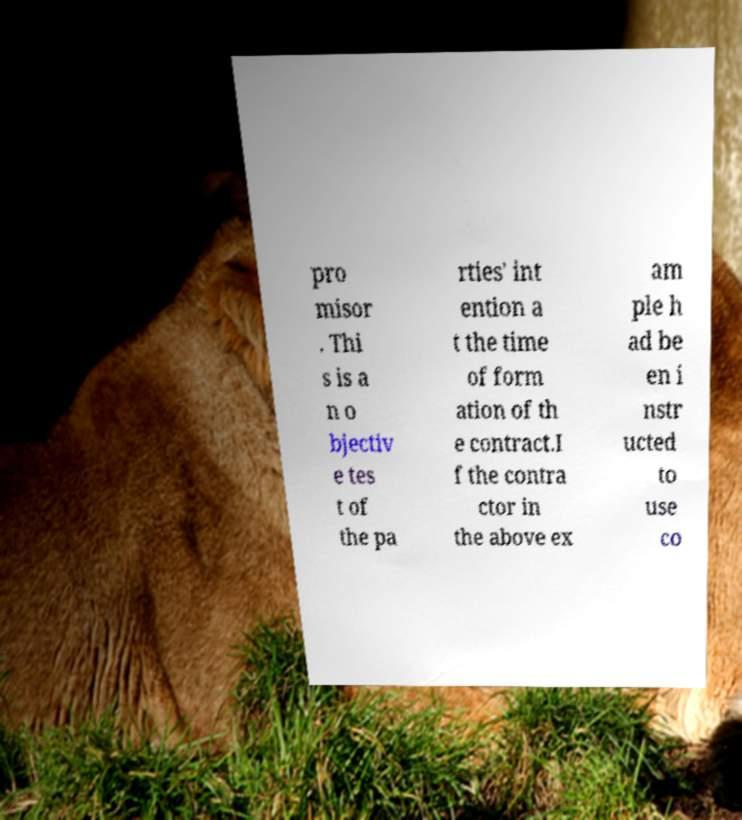For documentation purposes, I need the text within this image transcribed. Could you provide that? pro misor . Thi s is a n o bjectiv e tes t of the pa rties' int ention a t the time of form ation of th e contract.I f the contra ctor in the above ex am ple h ad be en i nstr ucted to use co 